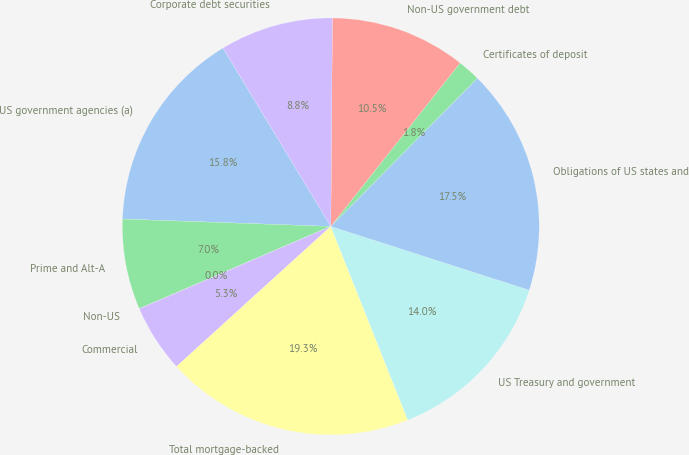Convert chart. <chart><loc_0><loc_0><loc_500><loc_500><pie_chart><fcel>US government agencies (a)<fcel>Prime and Alt-A<fcel>Non-US<fcel>Commercial<fcel>Total mortgage-backed<fcel>US Treasury and government<fcel>Obligations of US states and<fcel>Certificates of deposit<fcel>Non-US government debt<fcel>Corporate debt securities<nl><fcel>15.79%<fcel>7.02%<fcel>0.01%<fcel>5.27%<fcel>19.29%<fcel>14.03%<fcel>17.54%<fcel>1.76%<fcel>10.53%<fcel>8.77%<nl></chart> 